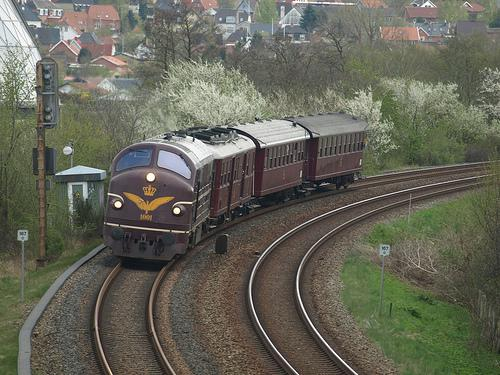Question: what is it?
Choices:
A. Bus.
B. Train.
C. Bikes.
D. Planes.
Answer with the letter. Answer: B Question: why is it there?
Choices:
A. For eating.
B. To move.
C. For playing.
D. For cooking.
Answer with the letter. Answer: B Question: who is on the train?
Choices:
A. People.
B. Captain.
C. Passengers.
D. Conductor.
Answer with the letter. Answer: A Question: what is on the tracks?
Choices:
A. Birds.
B. Grass.
C. Stones.
D. Train.
Answer with the letter. Answer: D 